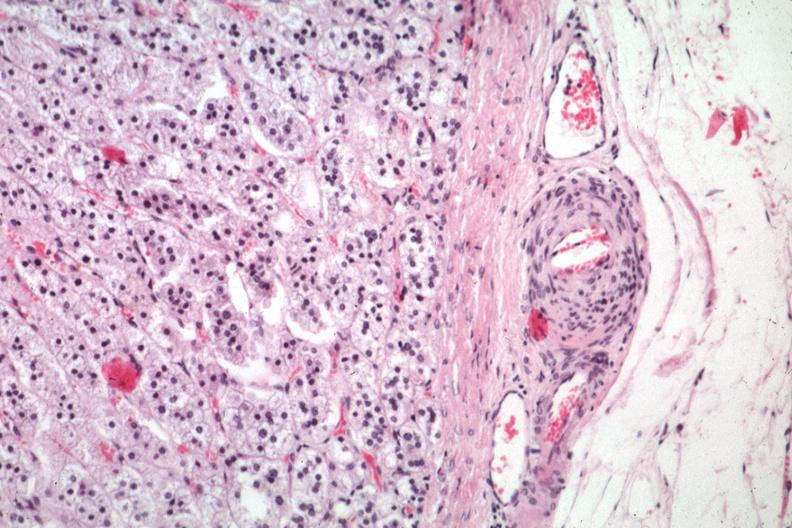s outside adrenal capsule section present?
Answer the question using a single word or phrase. No 